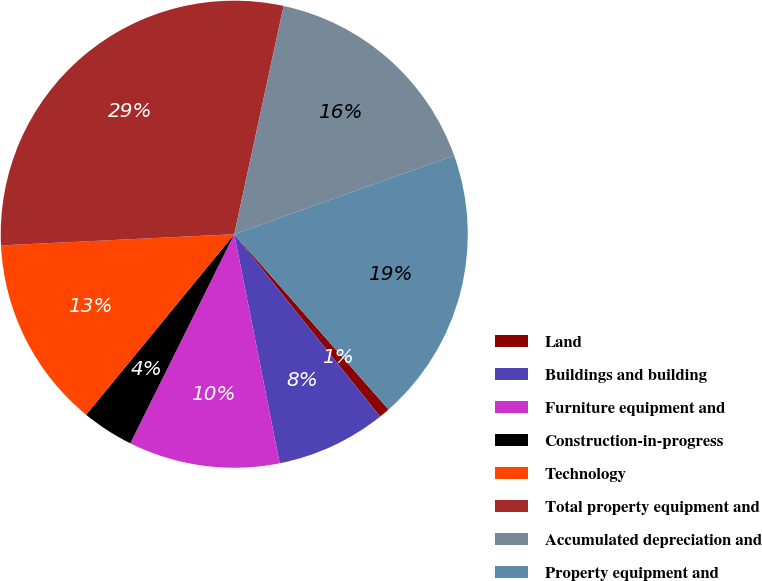Convert chart. <chart><loc_0><loc_0><loc_500><loc_500><pie_chart><fcel>Land<fcel>Buildings and building<fcel>Furniture equipment and<fcel>Construction-in-progress<fcel>Technology<fcel>Total property equipment and<fcel>Accumulated depreciation and<fcel>Property equipment and<nl><fcel>0.75%<fcel>7.62%<fcel>10.46%<fcel>3.59%<fcel>13.3%<fcel>29.15%<fcel>16.14%<fcel>18.98%<nl></chart> 